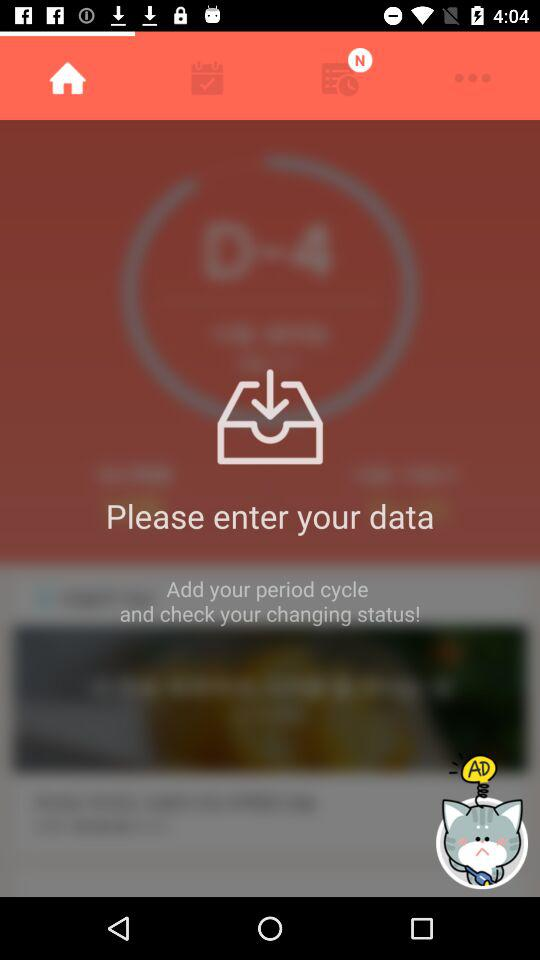Which tab is selected? The selected tab is "Home". 